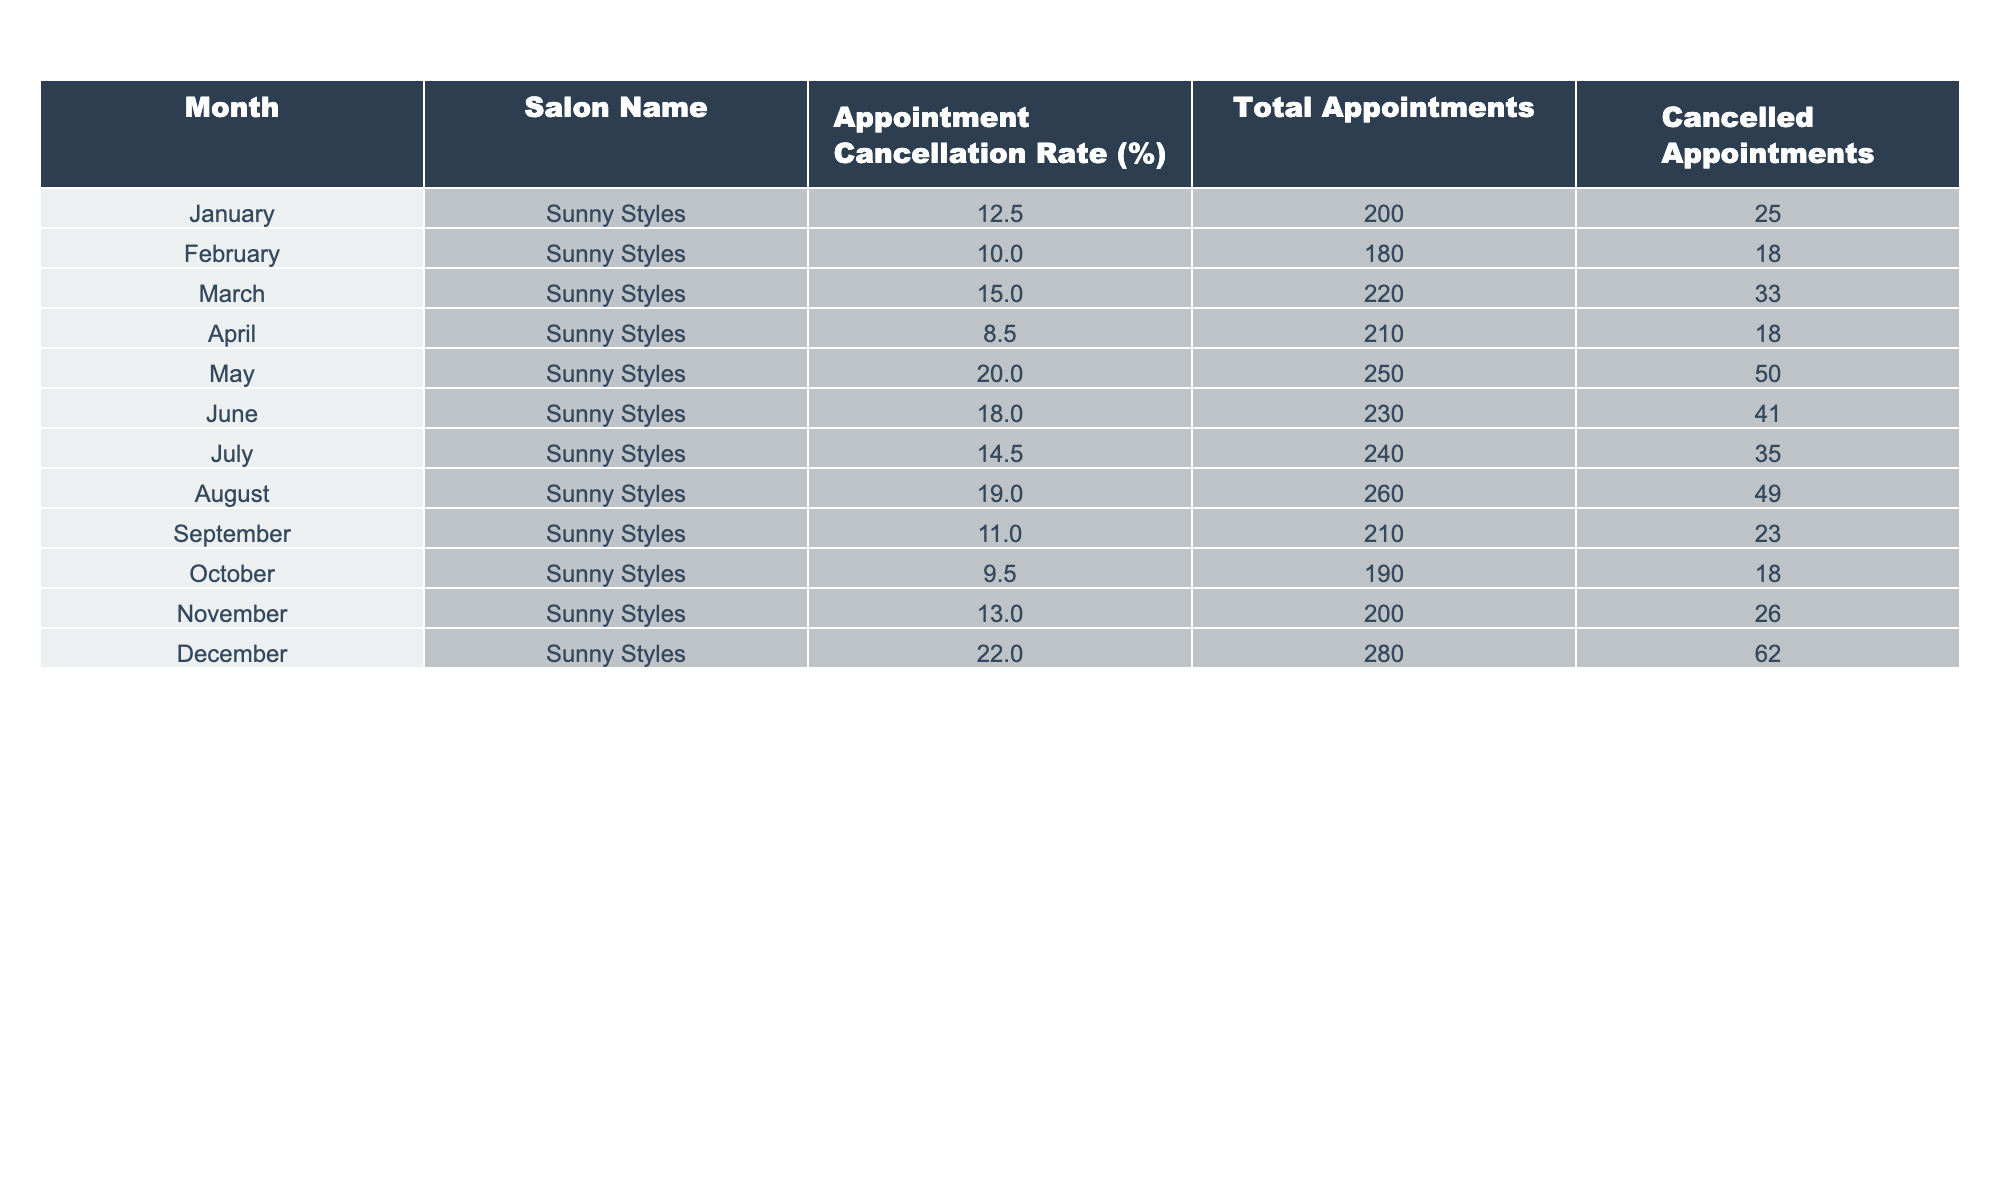What was the highest appointment cancellation rate recorded, and in which month did it occur? The highest appointment cancellation rate is 22.0%, which occurred in December. This is identified by scanning the 'Appointment Cancellation Rate (%)' column for the maximum value.
Answer: 22.0%, December What was the total number of appointments in May? In May, the total number of appointments listed is 250. This value is taken directly from the 'Total Appointments' column for May.
Answer: 250 In which month was the lowest appointment cancellation rate observed? The lowest appointment cancellation rate is 8.5%, observed in April. This is determined by comparing all rates listed in the 'Appointment Cancellation Rate (%)' column and identifying the lowest.
Answer: 8.5%, April What is the average appointment cancellation rate for the first half of the year (January to June)? To find the average for January to June, we sum the rates: (12.5 + 10.0 + 15.0 + 8.5 + 20.0 + 18.0) = 84.0, and divide by the number of months (6). Thus, the average cancellation rate is 84.0 / 6 = 14.0%.
Answer: 14.0% Is it true that more than 50 appointments were cancelled in May? In May, the 'Cancelled Appointments' value is 50, which does not exceed 50. Therefore, the statement is false.
Answer: No What is the difference between the cancellation rates in December and February? The cancellation rate in December is 22.0%, and in February it is 10.0%. To find the difference: 22.0% - 10.0% = 12.0%.
Answer: 12.0% Which month had the highest number of total appointments, and what was that number? December had the highest number of total appointments, which was 280. This is determined by examining the 'Total Appointments' column and identifying the maximum value along with its corresponding month.
Answer: 280, December What is the median appointment cancellation rate across all months? To find the median, we order the cancellation rates: 8.5%, 9.5%, 10.0%, 11.0%, 12.5%, 13.0%, 14.5%, 15.0%, 18.0%, 19.0%, 20.0%, 22.0%. Since there are 12 rates, the median is the average of the 6th and 7th values: (13.0% + 14.5%) / 2 = 13.75%.
Answer: 13.75% Did the salon experience a higher cancellation rate in June compared to January? In January, the cancellation rate is 12.5%, while in June, it is 18.0%. Since 18.0% is greater than 12.5%, the statement is true.
Answer: Yes Which two months had appointment cancellation rates that exceeded 20%? Looking at the cancellation rates, only December had a rate of 22.0%. No other month exceeds 20%, so the answer is that there are no two months.
Answer: None 